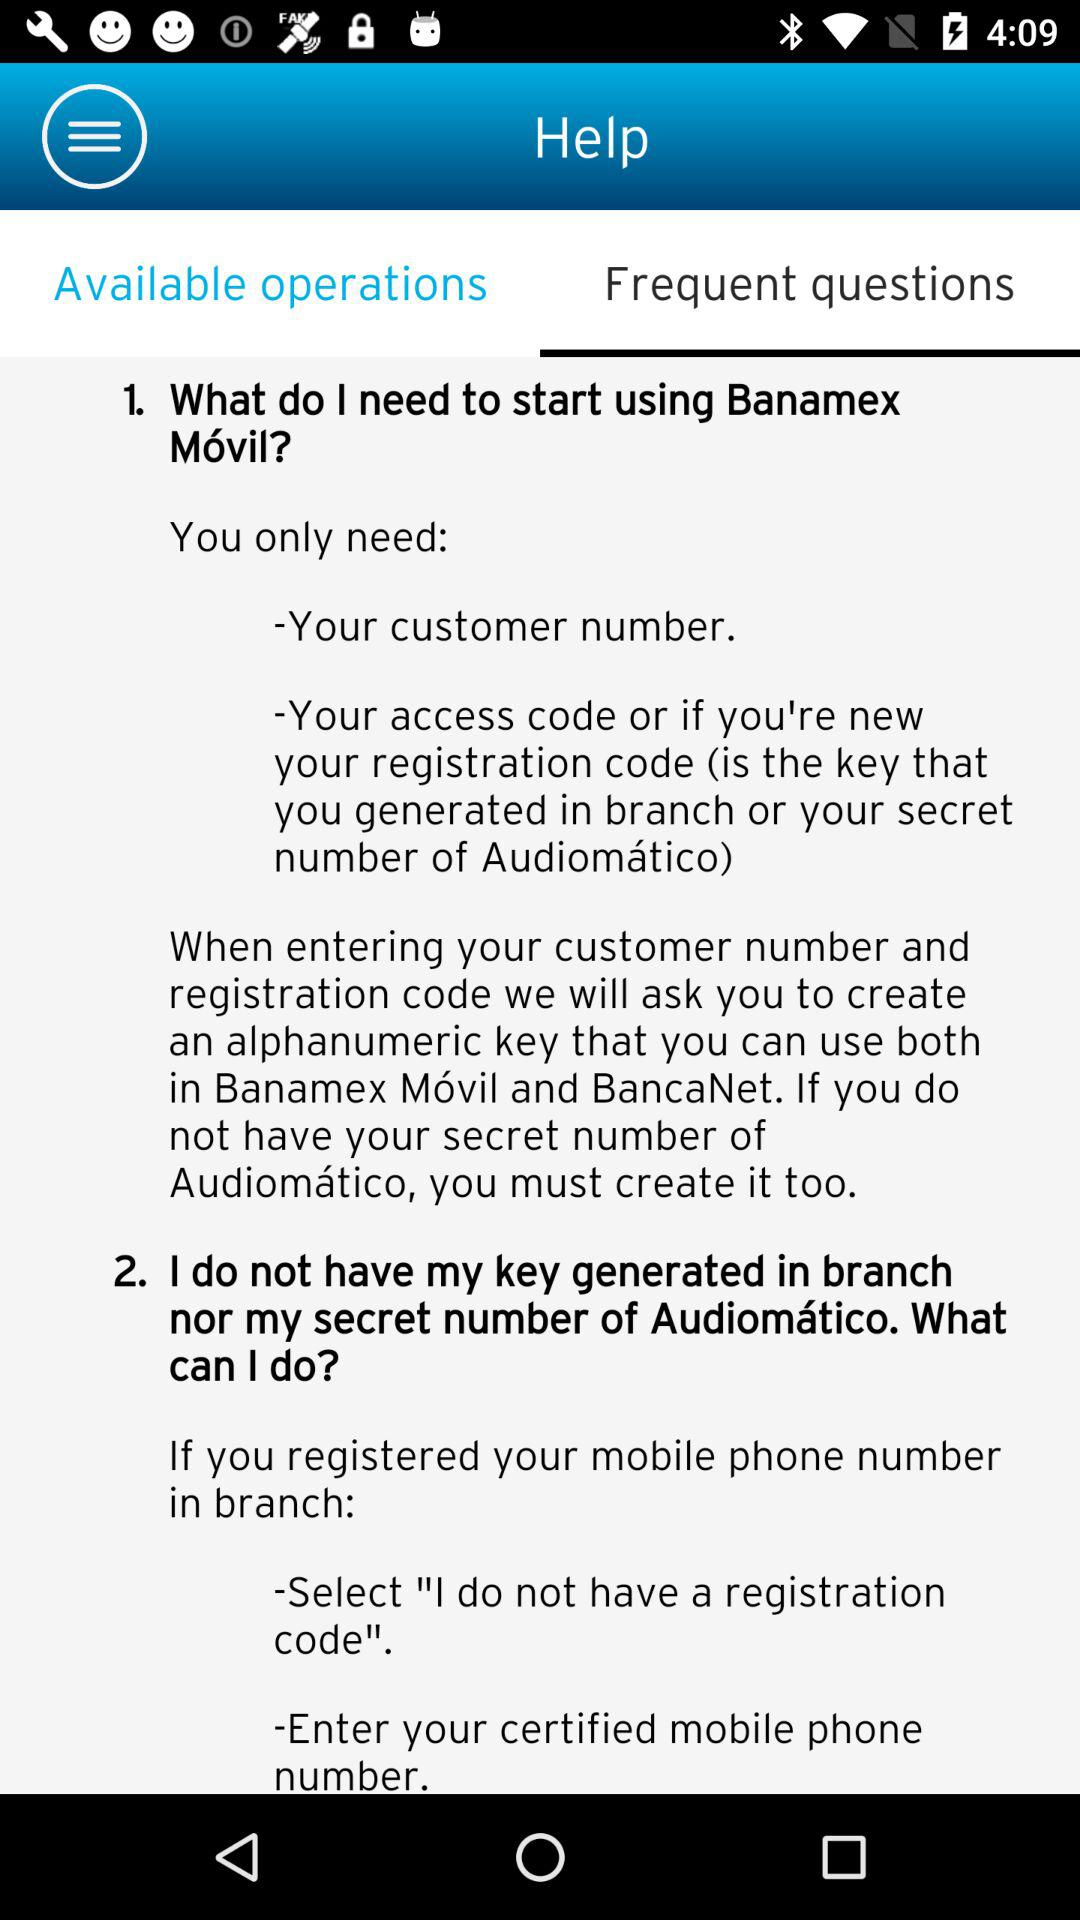How many steps do I need to follow to start using Banamex Móvil?
Answer the question using a single word or phrase. 2 